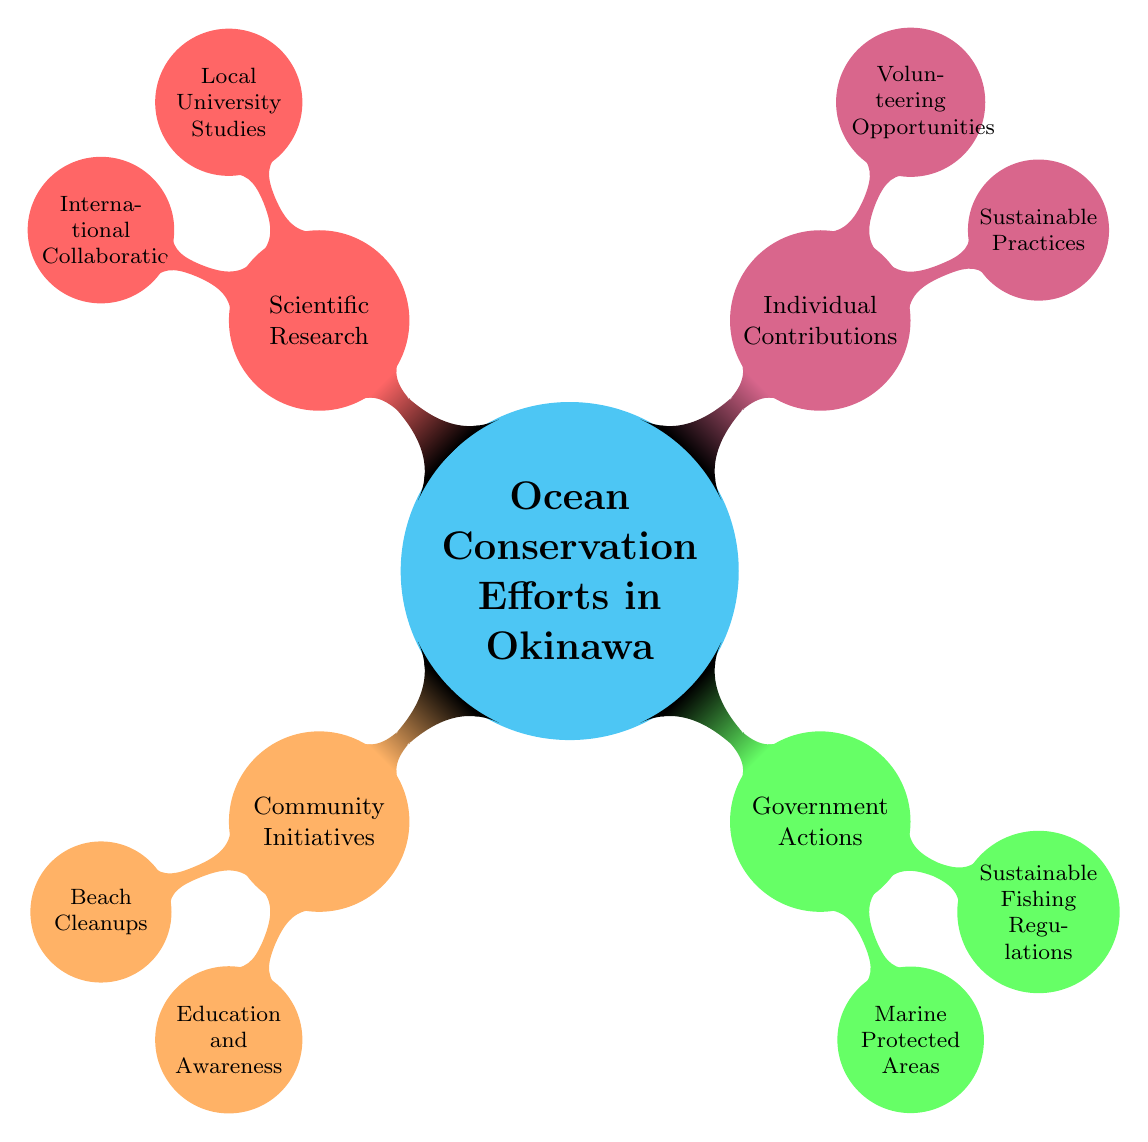What is the main topic of the mind map? The central node of the diagram clearly states "Ocean Conservation Efforts in Okinawa," which summarizes the primary focus of the mind map.
Answer: Ocean Conservation Efforts in Okinawa How many main categories are there in the diagram? The main branches stemming from the central node indicate that there are four categories: Community Initiatives, Government Actions, Individual Contributions, and Scientific Research.
Answer: Four What type of initiatives are categorized under Community Initiatives? By looking at the 'Community Initiatives' node, the sub-nodes, 'Beach Cleanups' and 'Education and Awareness,' clarify the types of initiatives under this category.
Answer: Beach Cleanups and Education and Awareness Which area is specifically mentioned under Government Actions for marine protection? The sub-node 'Marine Protected Areas' under the 'Government Actions' category shows that there are specific areas like 'Kerama Islands National Park' linked directly to this.
Answer: Kerama Islands National Park What can individuals do to contribute to ocean conservation? The 'Individual Contributions' section of the mind map contains two sub-nodes: 'Sustainable Practices' and 'Volunteering Opportunities,' providing clear actions that individuals can undertake.
Answer: Sustainable Practices and Volunteering Opportunities Which specific research collaboration is listed under Scientific Research? When examining the 'International Collaboration' node, 'WWF Coral Reef Studies’ fits under this category, making it a specific research initiative mentioned in the mind map.
Answer: WWF Coral Reef Studies How many opportunities for volunteering are listed in the diagram? The 'Volunteering Opportunities' node contains two specific initiatives, 'Sea Turtle Conservation Programs' and 'Coral Rehabilitation Projects,' indicating the number of volunteering opportunities available.
Answer: Two What node directly branches from Government Actions regarding fishing? The sub-node 'Sustainable Fishing Regulations' under the 'Government Actions' node directly addresses the fishing regulations in the context of ocean conservation efforts.
Answer: Sustainable Fishing Regulations Which educational program is mentioned as part of Community Initiatives? Looking at the 'Education and Awareness' aspect under 'Community Initiatives,' it specifies 'Okinawa Churaumi Aquarium Workshops' as an educational program.
Answer: Okinawa Churaumi Aquarium Workshops 